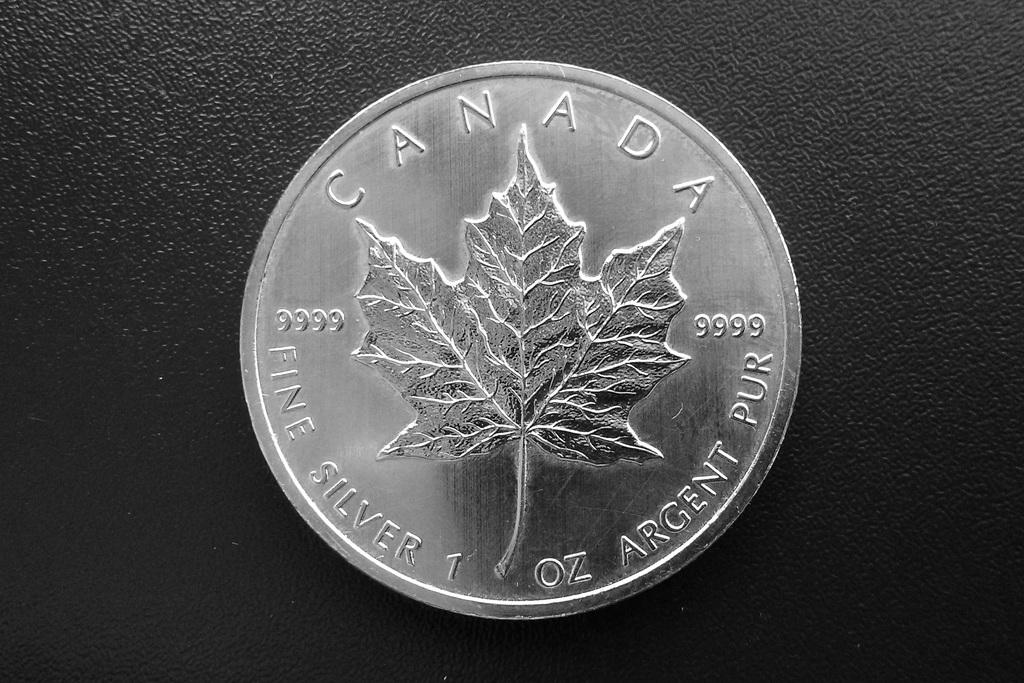The coin is from what country?
Keep it short and to the point. Canada. What year was this coin minted?
Provide a succinct answer. Unanswerable. 